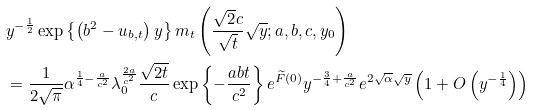<formula> <loc_0><loc_0><loc_500><loc_500>& y ^ { - \frac { 1 } { 2 } } \exp \left \{ \left ( b ^ { 2 } - u _ { b , t } \right ) y \right \} m _ { t } \left ( \frac { \sqrt { 2 } c } { \sqrt { t } } \sqrt { y } ; a , b , c , y _ { 0 } \right ) \\ & = \frac { 1 } { 2 \sqrt { \pi } } \alpha ^ { \frac { 1 } { 4 } - \frac { a } { c ^ { 2 } } } \lambda _ { 0 } ^ { \frac { 2 a } { c ^ { 2 } } } \frac { \sqrt { 2 t } } { c } \exp \left \{ - \frac { a b t } { c ^ { 2 } } \right \} e ^ { \widetilde { F } ( 0 ) } y ^ { - \frac { 3 } { 4 } + \frac { a } { c ^ { 2 } } } e ^ { 2 \sqrt { \alpha } \sqrt { y } } \left ( 1 + O \left ( y ^ { - \frac { 1 } { 4 } } \right ) \right )</formula> 